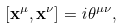<formula> <loc_0><loc_0><loc_500><loc_500>[ { \mathbf x } ^ { \mu } , { \mathbf x } ^ { \nu } ] = i \theta ^ { \mu \nu } ,</formula> 